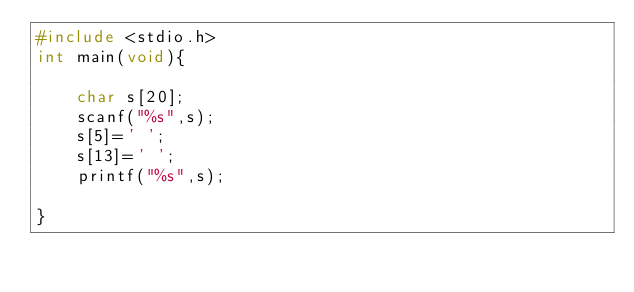Convert code to text. <code><loc_0><loc_0><loc_500><loc_500><_C_>#include <stdio.h>
int main(void){
    
    char s[20];
    scanf("%s",s);
    s[5]=' ';
    s[13]=' ';
    printf("%s",s);
    
}</code> 